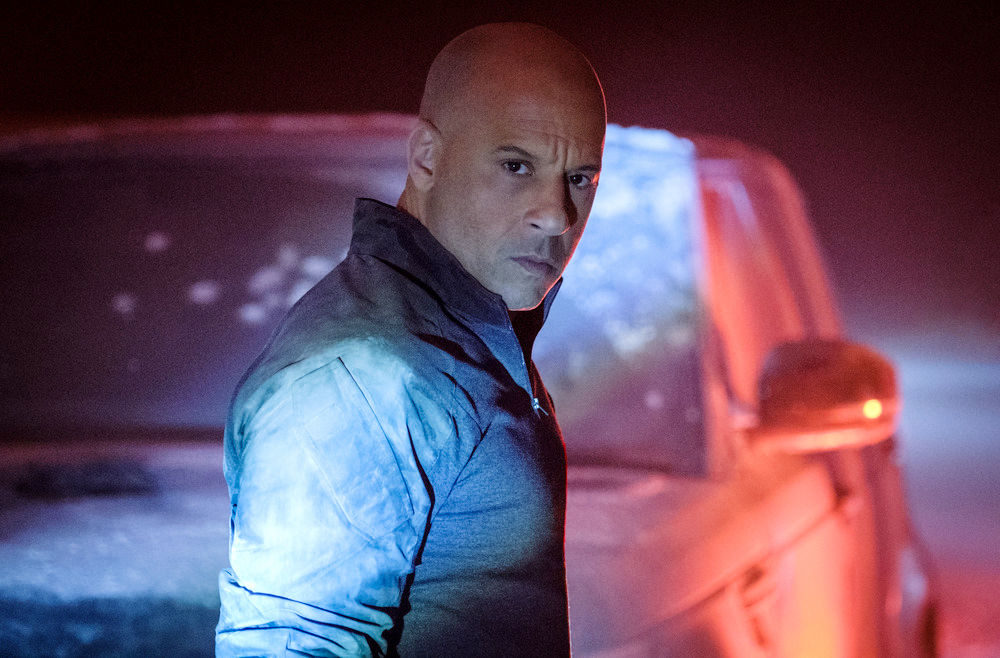Describe a scenario where the man is preparing for a high-speed chase. In the dimly lit, fog-covered parking garage, the man readies himself for a high-speed chase. He checks the fuel levels and the tire pressure of his modified car, ensuring everything is in perfect condition. The car, almost as imposing as its driver, shines through the fog with a hint of its metallic sheen. As he steps back, he tightens his grip on the steering wheel, glancing over his shoulder one last time to ensure no one is watching. The sound of distant sirens grows louder, signaling it is time to move. With a determined look, he jumps into the car, turns the ignition, and the engine roars to life. The chase is about to begin. 